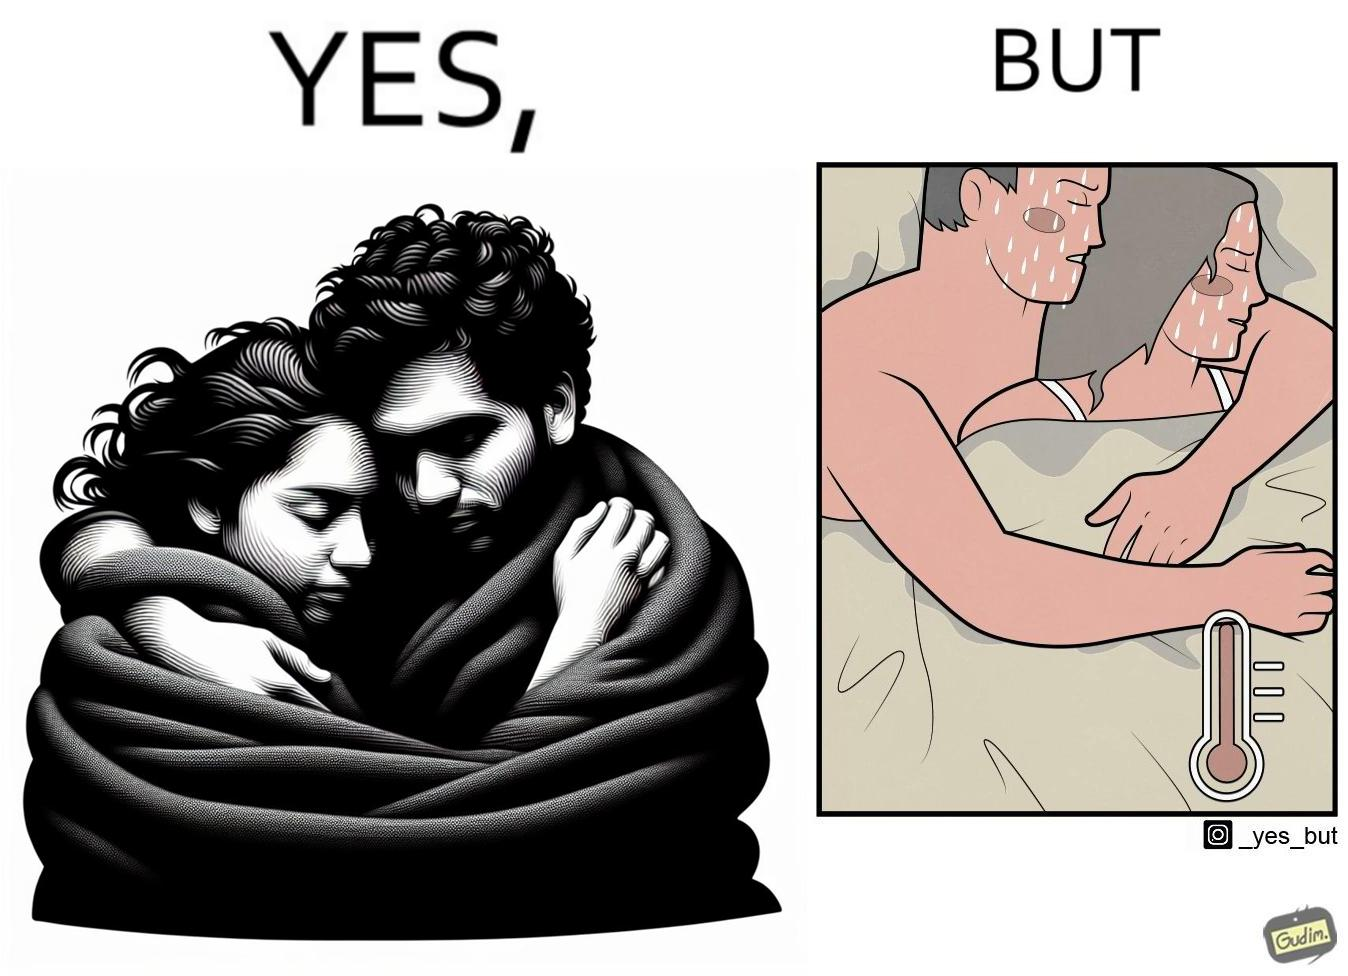What is shown in the left half versus the right half of this image? In the left part of the image: a couple cuddling together in a blanket In the right part of the image: a couple feeling sweaty while cuddling together in a blanket 